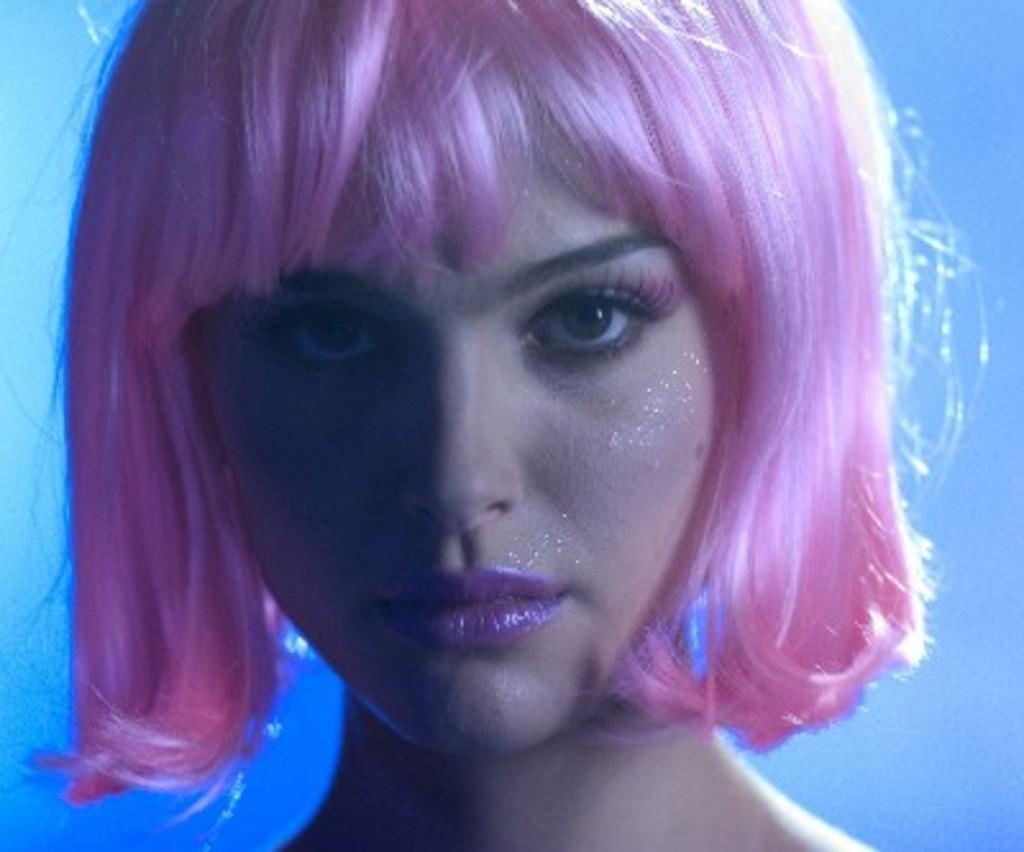Describe this image in one or two sentences. In this picture, we see a girl. Her hairs are in pink color. She is looking at the camera. In the background, it is blue color. 